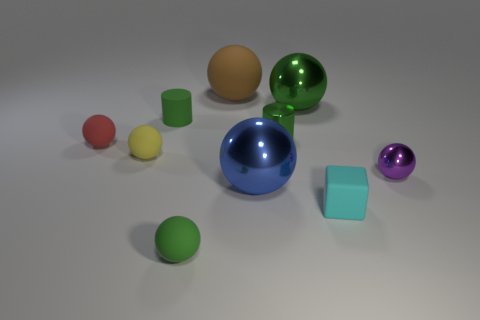What is the large brown ball that is behind the yellow ball that is left of the green rubber cylinder made of?
Keep it short and to the point. Rubber. Does the red sphere that is behind the blue thing have the same material as the green thing that is right of the small metallic cylinder?
Your answer should be compact. No. Is the number of tiny green matte balls in front of the small red rubber sphere greater than the number of large brown blocks?
Provide a succinct answer. Yes. There is a metal object that is behind the cylinder on the left side of the green ball in front of the cyan rubber thing; what is its shape?
Offer a terse response. Sphere. Do the small green rubber object that is in front of the red rubber thing and the small metallic thing that is behind the small red object have the same shape?
Provide a short and direct response. No. What number of cylinders are either small yellow matte objects or cyan rubber objects?
Offer a terse response. 0. Does the brown sphere have the same material as the small purple ball?
Offer a very short reply. No. What number of other objects are the same color as the rubber cylinder?
Give a very brief answer. 3. There is a tiny metal thing on the right side of the small green metallic cylinder; what shape is it?
Offer a terse response. Sphere. How many things are large brown rubber balls or cyan objects?
Ensure brevity in your answer.  2. 